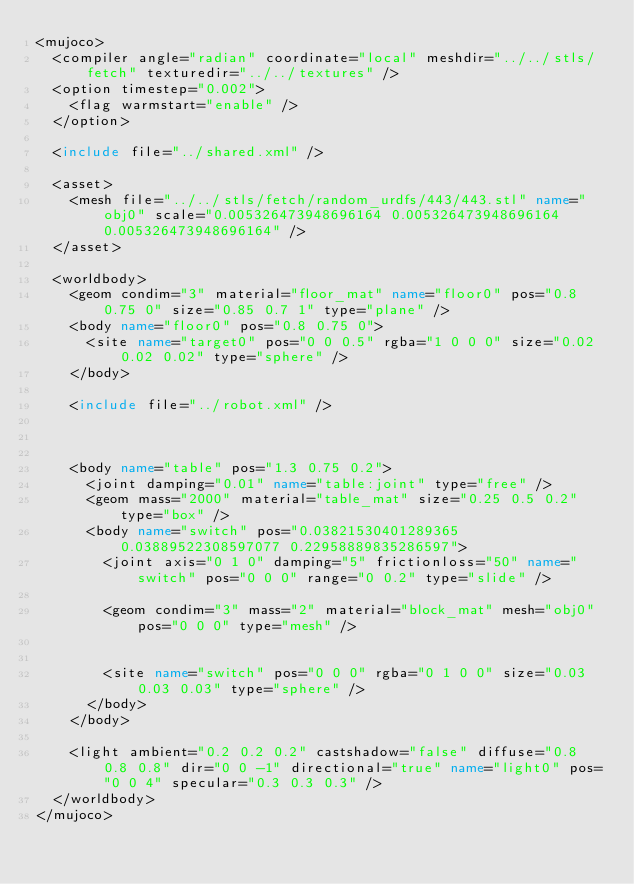Convert code to text. <code><loc_0><loc_0><loc_500><loc_500><_XML_><mujoco>
	<compiler angle="radian" coordinate="local" meshdir="../../stls/fetch" texturedir="../../textures" />
	<option timestep="0.002">
		<flag warmstart="enable" />
	</option>

	<include file="../shared.xml" />

	<asset>
		<mesh file="../../stls/fetch/random_urdfs/443/443.stl" name="obj0" scale="0.005326473948696164 0.005326473948696164 0.005326473948696164" />
	</asset>

	<worldbody>
		<geom condim="3" material="floor_mat" name="floor0" pos="0.8 0.75 0" size="0.85 0.7 1" type="plane" />
		<body name="floor0" pos="0.8 0.75 0">
			<site name="target0" pos="0 0 0.5" rgba="1 0 0 0" size="0.02 0.02 0.02" type="sphere" />
		</body>

		<include file="../robot.xml" />

		

		<body name="table" pos="1.3 0.75 0.2">
			<joint damping="0.01" name="table:joint" type="free" />
			<geom mass="2000" material="table_mat" size="0.25 0.5 0.2" type="box" />
			<body name="switch" pos="0.03821530401289365 0.03889522308597077 0.22958889835286597">
		    <joint axis="0 1 0" damping="5" frictionloss="50" name="switch" pos="0 0 0" range="0 0.2" type="slide" />
				
				<geom condim="3" mass="2" material="block_mat" mesh="obj0" pos="0 0 0" type="mesh" />
				
				
				<site name="switch" pos="0 0 0" rgba="0 1 0 0" size="0.03 0.03 0.03" type="sphere" />
			</body>
    </body>

		<light ambient="0.2 0.2 0.2" castshadow="false" diffuse="0.8 0.8 0.8" dir="0 0 -1" directional="true" name="light0" pos="0 0 4" specular="0.3 0.3 0.3" />
	</worldbody>
</mujoco></code> 